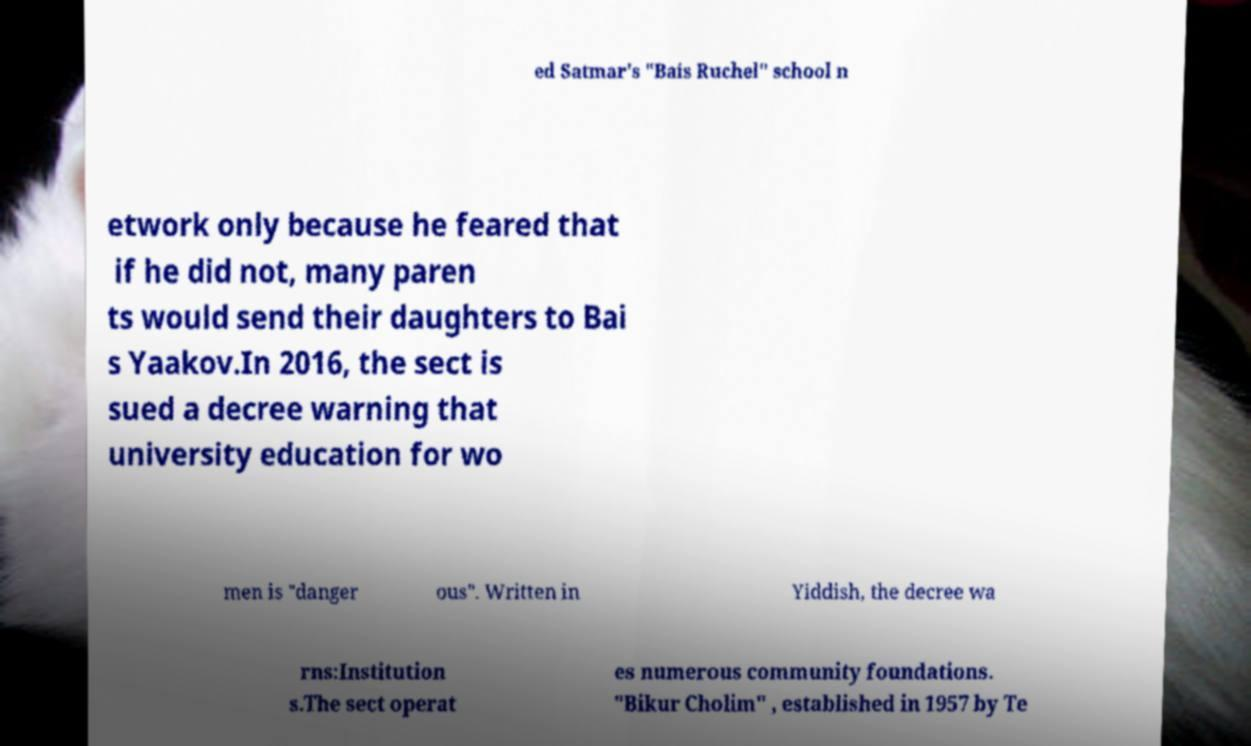Please read and relay the text visible in this image. What does it say? ed Satmar's "Bais Ruchel" school n etwork only because he feared that if he did not, many paren ts would send their daughters to Bai s Yaakov.In 2016, the sect is sued a decree warning that university education for wo men is "danger ous". Written in Yiddish, the decree wa rns:Institution s.The sect operat es numerous community foundations. "Bikur Cholim" , established in 1957 by Te 